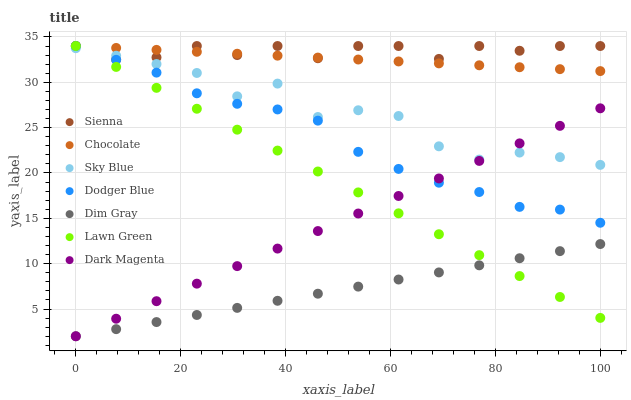Does Dim Gray have the minimum area under the curve?
Answer yes or no. Yes. Does Sienna have the maximum area under the curve?
Answer yes or no. Yes. Does Dark Magenta have the minimum area under the curve?
Answer yes or no. No. Does Dark Magenta have the maximum area under the curve?
Answer yes or no. No. Is Dim Gray the smoothest?
Answer yes or no. Yes. Is Sky Blue the roughest?
Answer yes or no. Yes. Is Dark Magenta the smoothest?
Answer yes or no. No. Is Dark Magenta the roughest?
Answer yes or no. No. Does Dim Gray have the lowest value?
Answer yes or no. Yes. Does Chocolate have the lowest value?
Answer yes or no. No. Does Dodger Blue have the highest value?
Answer yes or no. Yes. Does Dark Magenta have the highest value?
Answer yes or no. No. Is Dim Gray less than Sky Blue?
Answer yes or no. Yes. Is Chocolate greater than Dark Magenta?
Answer yes or no. Yes. Does Dodger Blue intersect Sky Blue?
Answer yes or no. Yes. Is Dodger Blue less than Sky Blue?
Answer yes or no. No. Is Dodger Blue greater than Sky Blue?
Answer yes or no. No. Does Dim Gray intersect Sky Blue?
Answer yes or no. No. 